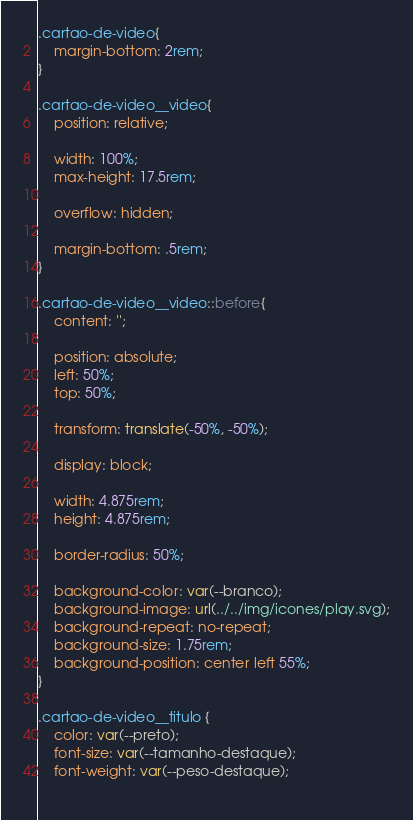Convert code to text. <code><loc_0><loc_0><loc_500><loc_500><_CSS_>.cartao-de-video{
    margin-bottom: 2rem;
}

.cartao-de-video__video{
    position: relative;

    width: 100%;
    max-height: 17.5rem;

    overflow: hidden;

    margin-bottom: .5rem;
}

.cartao-de-video__video::before{
    content: '';

    position: absolute;
    left: 50%;
    top: 50%;

    transform: translate(-50%, -50%);

    display: block;

    width: 4.875rem;
    height: 4.875rem;

    border-radius: 50%;

    background-color: var(--branco);
    background-image: url(../../img/icones/play.svg);
    background-repeat: no-repeat;
    background-size: 1.75rem;
    background-position: center left 55%;
}

.cartao-de-video__titulo {
    color: var(--preto);
    font-size: var(--tamanho-destaque);
    font-weight: var(--peso-destaque);
    </code> 